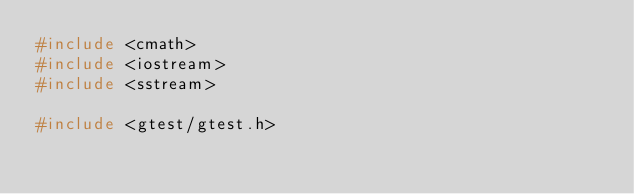<code> <loc_0><loc_0><loc_500><loc_500><_C++_>#include <cmath>
#include <iostream>
#include <sstream>

#include <gtest/gtest.h>
</code> 